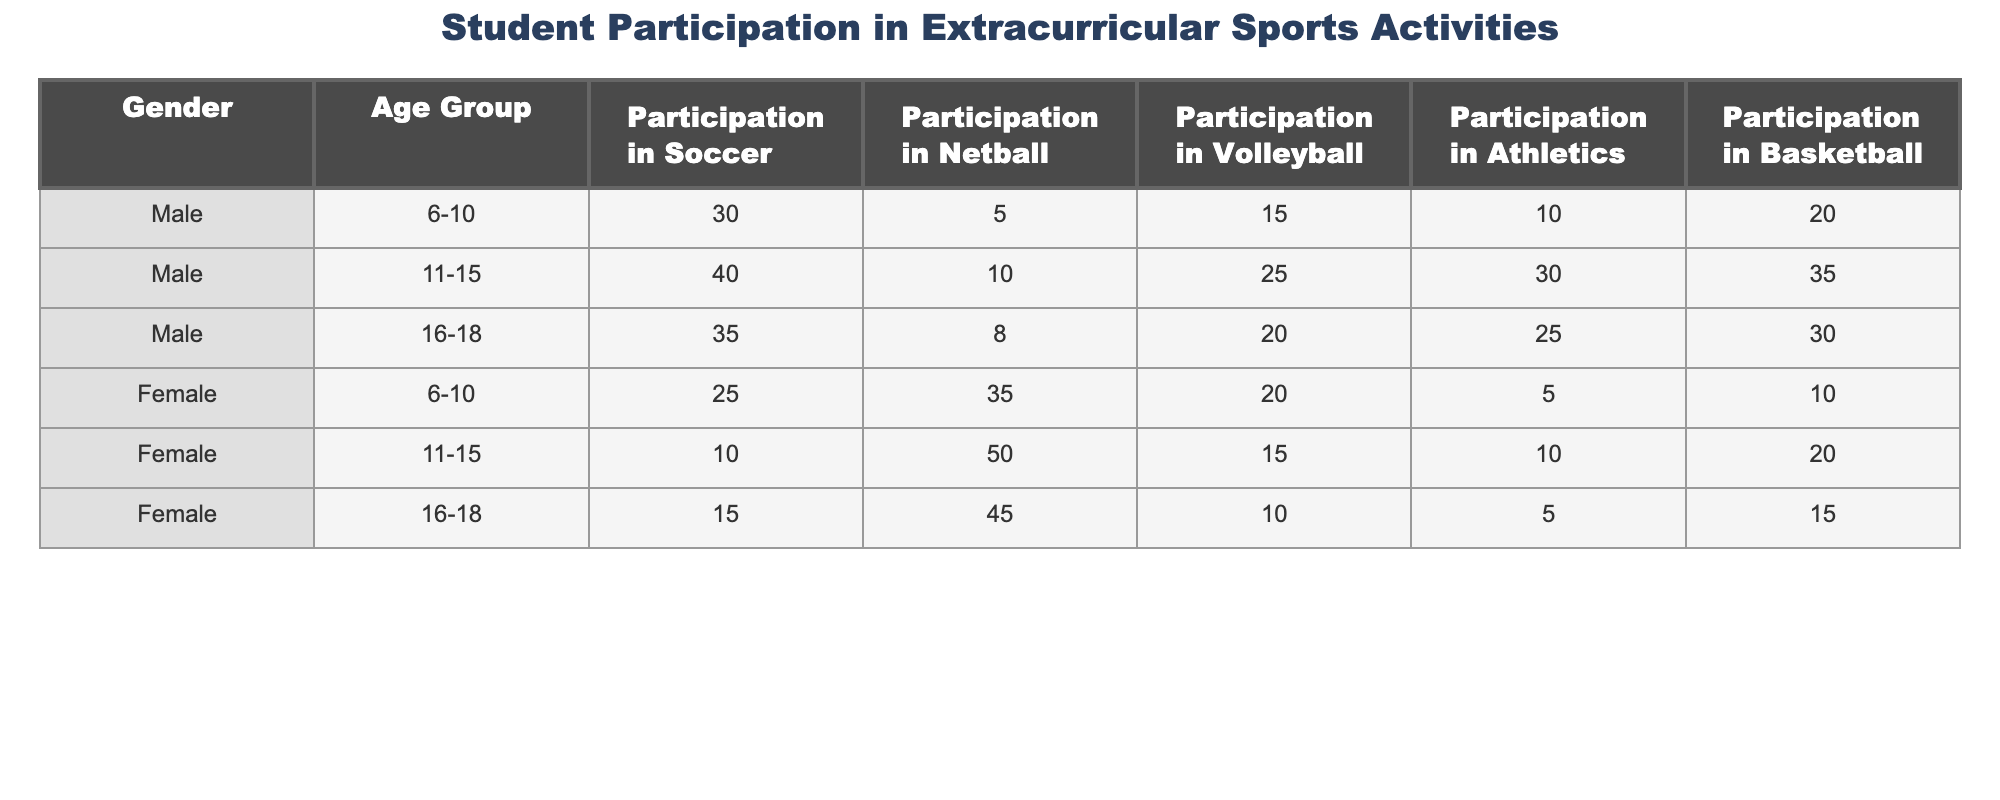What is the highest participation in athletics among male students? The table shows the participation in athletics for males across different age groups: 10 (age 6-10), 30 (age 11-15), and 25 (age 16-18). The highest value is 30 from the 11-15 age group.
Answer: 30 What is the total participation in volleyball for female students across all age groups? The participation in volleyball for females is: 20 (age 6-10), 15 (age 11-15), and 10 (age 16-18). Summing these values gives 20 + 15 + 10 = 45.
Answer: 45 Which age group has the highest participation in netball among female students? The table shows netball participation for females: 35 (6-10), 50 (11-15), and 45 (16-18). The highest value is 50 from the 11-15 age group.
Answer: 11-15 Is there a higher participation in basketball among males or females in the 16-18 age group? For males aged 16-18, participation in basketball is 30, while for females it is 15. Therefore, males have higher participation.
Answer: Yes, males have higher participation What is the average participation in soccer for male students? The participation in soccer for males is 30 (6-10), 40 (11-15), and 35 (16-18). Adding these gives 30 + 40 + 35 = 105. The average is 105 / 3 = 35.
Answer: 35 Which gender has more participants in athletics in the 11-15 age group? Males have 30 participants and females have 10 participants in athletics for the age group 11-15. Therefore, males have more participants.
Answer: Males What is the total participation in sports (soccer, netball, volleyball, athletics, and basketball) for female students aged 11-15? The participation for females aged 11-15 is: 10 (soccer) + 50 (netball) + 15 (volleyball) + 10 (athletics) + 20 (basketball). The total is 10 + 50 + 15 + 10 + 20 = 105.
Answer: 105 In which sport do male students aged 6-10 participate the least? Looking at the participation for males aged 6-10: 30 (soccer), 5 (netball), 15 (volleyball), 10 (athletics), and 20 (basketball). The lowest participation is in netball with 5.
Answer: Netball What is the difference in participation in soccer between males aged 11-15 and females aged 11-15? Males aged 11-15 have 40 in soccer while females in the same age group have 10. The difference is 40 - 10 = 30.
Answer: 30 Which age group has the overall highest participation in sports among male students when considering all activities? For males: 6-10 has totals: 30 + 5 + 15 + 10 + 20 = 80; 11-15 has: 40 + 10 + 25 + 30 + 35 = 150; 16-18 has: 35 + 8 + 20 + 25 + 30 = 118. The highest is 150 for age group 11-15.
Answer: 11-15 